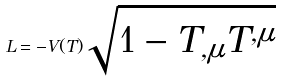<formula> <loc_0><loc_0><loc_500><loc_500>L = - V ( T ) \sqrt { 1 - T _ { , \mu } T ^ { , \mu } }</formula> 